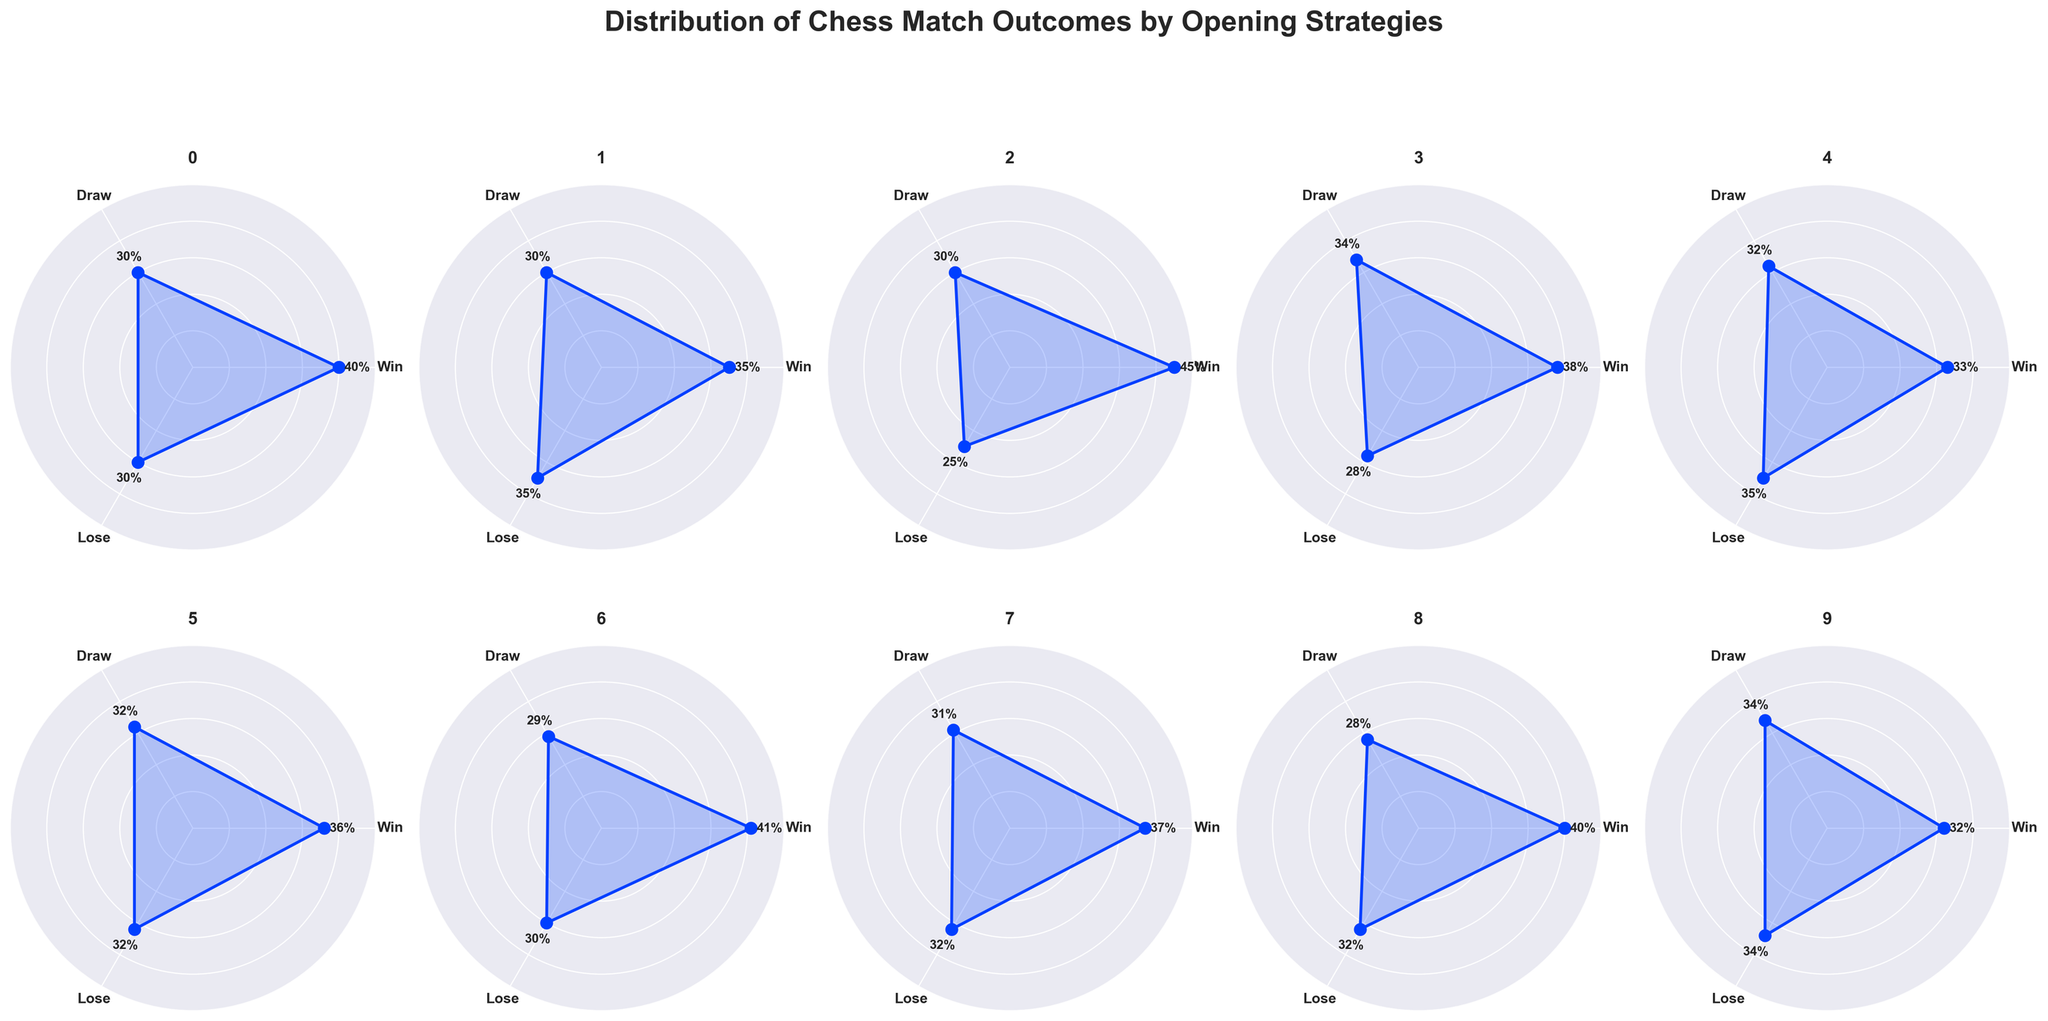How many opening strategies are depicted in the figure? Count the total number of different opening strategies shown. This number corresponds to each subplot in the figure.
Answer: 10 What is the title of the figure? The title of the figure is mentioned at the top of the figure, summarizing the overall information displayed.
Answer: Distribution of Chess Match Outcomes by Opening Strategies Which opening strategy has the highest win percentage? Examine each subplot, and look for the highest value under the 'Win' percentage for each opening strategy. The one with the highest value will be the answer.
Answer: Ruy Lopez Which opening strategy has an equal percentage of wins and losses? Check each subplot and find the strategy where the 'Win' and 'Lose' percentages are identical.
Answer: French Defense What is the combined win percentage of the Sicilian Defense and the Ruy Lopez strategies? Add the win percentages of the Sicilian Defense (40%) and the Ruy Lopez (45%) to get the combined percentage.
Answer: 85% Which opening strategy has the smallest difference between win and draw percentages? Calculate the difference between 'Win' and 'Draw' percentages for each strategy and identify the smallest difference.
Answer: Scandinavian Defense How many strategies have a losing percentage greater than 30%? Count the number of subplots where the 'Lose' percentage is greater than 30%.
Answer: 7 In which strategy are the win, draw, and lose percentages closest to each other? Look for the subplot where the difference between 'Win', 'Draw', and 'Lose' percentages is minimal, implying the values are closest to each other.
Answer: Scandinavian Defense Which opening strategy has the highest draw percentage? Compare the 'Draw' percentages across all subplots to find the strategy with the highest percentage.
Answer: Scandinavian Defense What is the average win percentage across all the depicted opening strategies? Sum the win percentages for all opening strategies and divide by the number of strategies (10). (40+35+45+38+33+36+41+37+40+32)/10 = 37.7%
Answer: 37.7% 